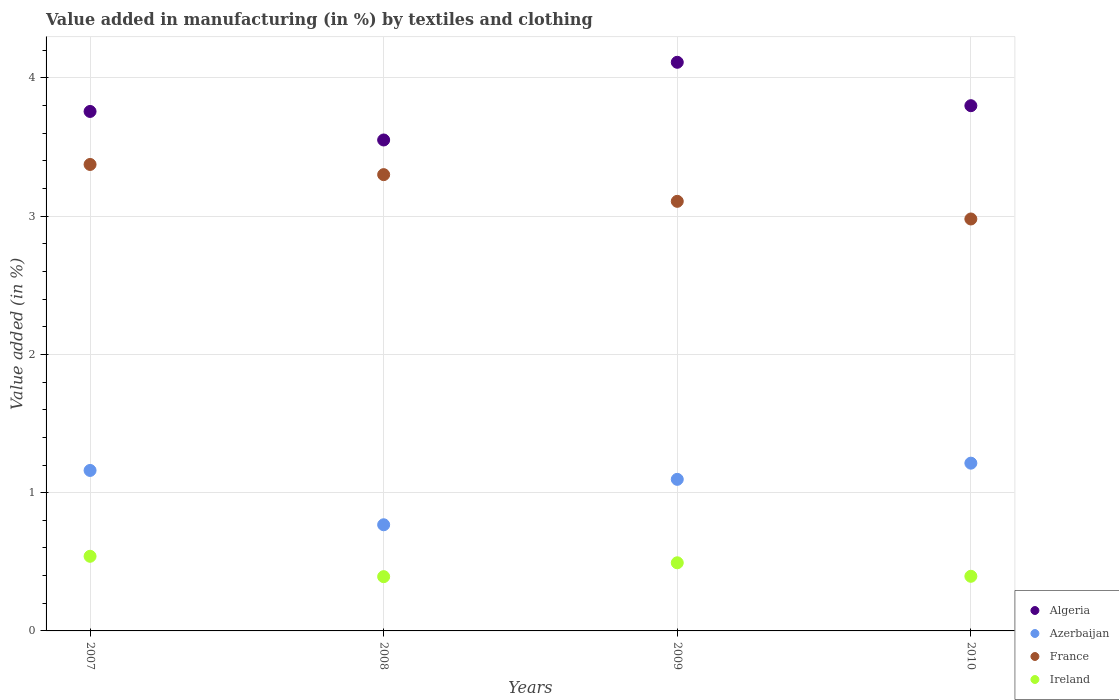How many different coloured dotlines are there?
Make the answer very short. 4. What is the percentage of value added in manufacturing by textiles and clothing in Azerbaijan in 2007?
Make the answer very short. 1.16. Across all years, what is the maximum percentage of value added in manufacturing by textiles and clothing in Ireland?
Offer a terse response. 0.54. Across all years, what is the minimum percentage of value added in manufacturing by textiles and clothing in Ireland?
Your answer should be very brief. 0.39. In which year was the percentage of value added in manufacturing by textiles and clothing in Azerbaijan maximum?
Offer a very short reply. 2010. What is the total percentage of value added in manufacturing by textiles and clothing in Algeria in the graph?
Your answer should be compact. 15.22. What is the difference between the percentage of value added in manufacturing by textiles and clothing in Azerbaijan in 2009 and that in 2010?
Offer a very short reply. -0.12. What is the difference between the percentage of value added in manufacturing by textiles and clothing in France in 2010 and the percentage of value added in manufacturing by textiles and clothing in Algeria in 2007?
Your response must be concise. -0.78. What is the average percentage of value added in manufacturing by textiles and clothing in Azerbaijan per year?
Provide a short and direct response. 1.06. In the year 2010, what is the difference between the percentage of value added in manufacturing by textiles and clothing in France and percentage of value added in manufacturing by textiles and clothing in Ireland?
Keep it short and to the point. 2.58. In how many years, is the percentage of value added in manufacturing by textiles and clothing in Algeria greater than 3.8 %?
Ensure brevity in your answer.  1. What is the ratio of the percentage of value added in manufacturing by textiles and clothing in Ireland in 2007 to that in 2009?
Provide a short and direct response. 1.1. Is the difference between the percentage of value added in manufacturing by textiles and clothing in France in 2007 and 2009 greater than the difference between the percentage of value added in manufacturing by textiles and clothing in Ireland in 2007 and 2009?
Keep it short and to the point. Yes. What is the difference between the highest and the second highest percentage of value added in manufacturing by textiles and clothing in France?
Provide a succinct answer. 0.07. What is the difference between the highest and the lowest percentage of value added in manufacturing by textiles and clothing in Ireland?
Make the answer very short. 0.15. Is it the case that in every year, the sum of the percentage of value added in manufacturing by textiles and clothing in France and percentage of value added in manufacturing by textiles and clothing in Algeria  is greater than the sum of percentage of value added in manufacturing by textiles and clothing in Ireland and percentage of value added in manufacturing by textiles and clothing in Azerbaijan?
Provide a short and direct response. Yes. Is the percentage of value added in manufacturing by textiles and clothing in France strictly greater than the percentage of value added in manufacturing by textiles and clothing in Algeria over the years?
Keep it short and to the point. No. How many dotlines are there?
Keep it short and to the point. 4. What is the difference between two consecutive major ticks on the Y-axis?
Make the answer very short. 1. Are the values on the major ticks of Y-axis written in scientific E-notation?
Your response must be concise. No. Where does the legend appear in the graph?
Your answer should be very brief. Bottom right. How many legend labels are there?
Keep it short and to the point. 4. How are the legend labels stacked?
Provide a short and direct response. Vertical. What is the title of the graph?
Your response must be concise. Value added in manufacturing (in %) by textiles and clothing. Does "Euro area" appear as one of the legend labels in the graph?
Provide a short and direct response. No. What is the label or title of the Y-axis?
Offer a terse response. Value added (in %). What is the Value added (in %) of Algeria in 2007?
Provide a short and direct response. 3.76. What is the Value added (in %) of Azerbaijan in 2007?
Give a very brief answer. 1.16. What is the Value added (in %) of France in 2007?
Provide a succinct answer. 3.37. What is the Value added (in %) of Ireland in 2007?
Give a very brief answer. 0.54. What is the Value added (in %) in Algeria in 2008?
Your answer should be very brief. 3.55. What is the Value added (in %) of Azerbaijan in 2008?
Your answer should be very brief. 0.77. What is the Value added (in %) of France in 2008?
Your answer should be very brief. 3.3. What is the Value added (in %) in Ireland in 2008?
Make the answer very short. 0.39. What is the Value added (in %) of Algeria in 2009?
Keep it short and to the point. 4.11. What is the Value added (in %) of Azerbaijan in 2009?
Your answer should be compact. 1.1. What is the Value added (in %) of France in 2009?
Your response must be concise. 3.11. What is the Value added (in %) in Ireland in 2009?
Provide a short and direct response. 0.49. What is the Value added (in %) in Algeria in 2010?
Your response must be concise. 3.8. What is the Value added (in %) in Azerbaijan in 2010?
Give a very brief answer. 1.21. What is the Value added (in %) in France in 2010?
Provide a short and direct response. 2.98. What is the Value added (in %) of Ireland in 2010?
Keep it short and to the point. 0.4. Across all years, what is the maximum Value added (in %) in Algeria?
Provide a succinct answer. 4.11. Across all years, what is the maximum Value added (in %) in Azerbaijan?
Keep it short and to the point. 1.21. Across all years, what is the maximum Value added (in %) of France?
Your answer should be compact. 3.37. Across all years, what is the maximum Value added (in %) of Ireland?
Provide a succinct answer. 0.54. Across all years, what is the minimum Value added (in %) in Algeria?
Make the answer very short. 3.55. Across all years, what is the minimum Value added (in %) in Azerbaijan?
Keep it short and to the point. 0.77. Across all years, what is the minimum Value added (in %) of France?
Offer a very short reply. 2.98. Across all years, what is the minimum Value added (in %) in Ireland?
Keep it short and to the point. 0.39. What is the total Value added (in %) in Algeria in the graph?
Offer a very short reply. 15.22. What is the total Value added (in %) in Azerbaijan in the graph?
Provide a short and direct response. 4.24. What is the total Value added (in %) in France in the graph?
Offer a very short reply. 12.76. What is the total Value added (in %) in Ireland in the graph?
Make the answer very short. 1.82. What is the difference between the Value added (in %) of Algeria in 2007 and that in 2008?
Provide a succinct answer. 0.21. What is the difference between the Value added (in %) of Azerbaijan in 2007 and that in 2008?
Offer a terse response. 0.39. What is the difference between the Value added (in %) in France in 2007 and that in 2008?
Provide a succinct answer. 0.07. What is the difference between the Value added (in %) of Ireland in 2007 and that in 2008?
Give a very brief answer. 0.15. What is the difference between the Value added (in %) in Algeria in 2007 and that in 2009?
Your answer should be compact. -0.36. What is the difference between the Value added (in %) in Azerbaijan in 2007 and that in 2009?
Your response must be concise. 0.06. What is the difference between the Value added (in %) in France in 2007 and that in 2009?
Ensure brevity in your answer.  0.27. What is the difference between the Value added (in %) of Ireland in 2007 and that in 2009?
Offer a very short reply. 0.05. What is the difference between the Value added (in %) of Algeria in 2007 and that in 2010?
Make the answer very short. -0.04. What is the difference between the Value added (in %) of Azerbaijan in 2007 and that in 2010?
Offer a very short reply. -0.05. What is the difference between the Value added (in %) in France in 2007 and that in 2010?
Your answer should be very brief. 0.39. What is the difference between the Value added (in %) of Ireland in 2007 and that in 2010?
Provide a succinct answer. 0.14. What is the difference between the Value added (in %) of Algeria in 2008 and that in 2009?
Give a very brief answer. -0.56. What is the difference between the Value added (in %) in Azerbaijan in 2008 and that in 2009?
Provide a short and direct response. -0.33. What is the difference between the Value added (in %) in France in 2008 and that in 2009?
Your response must be concise. 0.19. What is the difference between the Value added (in %) of Ireland in 2008 and that in 2009?
Offer a very short reply. -0.1. What is the difference between the Value added (in %) of Algeria in 2008 and that in 2010?
Provide a succinct answer. -0.25. What is the difference between the Value added (in %) of Azerbaijan in 2008 and that in 2010?
Keep it short and to the point. -0.45. What is the difference between the Value added (in %) in France in 2008 and that in 2010?
Keep it short and to the point. 0.32. What is the difference between the Value added (in %) in Ireland in 2008 and that in 2010?
Offer a terse response. -0. What is the difference between the Value added (in %) of Algeria in 2009 and that in 2010?
Offer a very short reply. 0.31. What is the difference between the Value added (in %) in Azerbaijan in 2009 and that in 2010?
Offer a terse response. -0.12. What is the difference between the Value added (in %) of France in 2009 and that in 2010?
Provide a succinct answer. 0.13. What is the difference between the Value added (in %) of Ireland in 2009 and that in 2010?
Your response must be concise. 0.1. What is the difference between the Value added (in %) of Algeria in 2007 and the Value added (in %) of Azerbaijan in 2008?
Offer a terse response. 2.99. What is the difference between the Value added (in %) in Algeria in 2007 and the Value added (in %) in France in 2008?
Make the answer very short. 0.46. What is the difference between the Value added (in %) in Algeria in 2007 and the Value added (in %) in Ireland in 2008?
Provide a short and direct response. 3.36. What is the difference between the Value added (in %) of Azerbaijan in 2007 and the Value added (in %) of France in 2008?
Offer a very short reply. -2.14. What is the difference between the Value added (in %) in Azerbaijan in 2007 and the Value added (in %) in Ireland in 2008?
Make the answer very short. 0.77. What is the difference between the Value added (in %) of France in 2007 and the Value added (in %) of Ireland in 2008?
Give a very brief answer. 2.98. What is the difference between the Value added (in %) of Algeria in 2007 and the Value added (in %) of Azerbaijan in 2009?
Provide a short and direct response. 2.66. What is the difference between the Value added (in %) in Algeria in 2007 and the Value added (in %) in France in 2009?
Make the answer very short. 0.65. What is the difference between the Value added (in %) of Algeria in 2007 and the Value added (in %) of Ireland in 2009?
Give a very brief answer. 3.26. What is the difference between the Value added (in %) in Azerbaijan in 2007 and the Value added (in %) in France in 2009?
Your answer should be compact. -1.95. What is the difference between the Value added (in %) in Azerbaijan in 2007 and the Value added (in %) in Ireland in 2009?
Give a very brief answer. 0.67. What is the difference between the Value added (in %) of France in 2007 and the Value added (in %) of Ireland in 2009?
Give a very brief answer. 2.88. What is the difference between the Value added (in %) in Algeria in 2007 and the Value added (in %) in Azerbaijan in 2010?
Your response must be concise. 2.54. What is the difference between the Value added (in %) in Algeria in 2007 and the Value added (in %) in France in 2010?
Keep it short and to the point. 0.78. What is the difference between the Value added (in %) in Algeria in 2007 and the Value added (in %) in Ireland in 2010?
Offer a very short reply. 3.36. What is the difference between the Value added (in %) of Azerbaijan in 2007 and the Value added (in %) of France in 2010?
Your answer should be very brief. -1.82. What is the difference between the Value added (in %) in Azerbaijan in 2007 and the Value added (in %) in Ireland in 2010?
Offer a very short reply. 0.77. What is the difference between the Value added (in %) of France in 2007 and the Value added (in %) of Ireland in 2010?
Offer a terse response. 2.98. What is the difference between the Value added (in %) of Algeria in 2008 and the Value added (in %) of Azerbaijan in 2009?
Offer a very short reply. 2.45. What is the difference between the Value added (in %) in Algeria in 2008 and the Value added (in %) in France in 2009?
Provide a short and direct response. 0.44. What is the difference between the Value added (in %) in Algeria in 2008 and the Value added (in %) in Ireland in 2009?
Provide a succinct answer. 3.06. What is the difference between the Value added (in %) of Azerbaijan in 2008 and the Value added (in %) of France in 2009?
Ensure brevity in your answer.  -2.34. What is the difference between the Value added (in %) in Azerbaijan in 2008 and the Value added (in %) in Ireland in 2009?
Make the answer very short. 0.27. What is the difference between the Value added (in %) of France in 2008 and the Value added (in %) of Ireland in 2009?
Keep it short and to the point. 2.81. What is the difference between the Value added (in %) of Algeria in 2008 and the Value added (in %) of Azerbaijan in 2010?
Your response must be concise. 2.34. What is the difference between the Value added (in %) in Algeria in 2008 and the Value added (in %) in France in 2010?
Your answer should be very brief. 0.57. What is the difference between the Value added (in %) of Algeria in 2008 and the Value added (in %) of Ireland in 2010?
Offer a terse response. 3.16. What is the difference between the Value added (in %) in Azerbaijan in 2008 and the Value added (in %) in France in 2010?
Ensure brevity in your answer.  -2.21. What is the difference between the Value added (in %) of Azerbaijan in 2008 and the Value added (in %) of Ireland in 2010?
Your answer should be very brief. 0.37. What is the difference between the Value added (in %) of France in 2008 and the Value added (in %) of Ireland in 2010?
Your answer should be compact. 2.9. What is the difference between the Value added (in %) in Algeria in 2009 and the Value added (in %) in Azerbaijan in 2010?
Give a very brief answer. 2.9. What is the difference between the Value added (in %) of Algeria in 2009 and the Value added (in %) of France in 2010?
Offer a terse response. 1.13. What is the difference between the Value added (in %) in Algeria in 2009 and the Value added (in %) in Ireland in 2010?
Provide a short and direct response. 3.72. What is the difference between the Value added (in %) of Azerbaijan in 2009 and the Value added (in %) of France in 2010?
Your answer should be compact. -1.88. What is the difference between the Value added (in %) of Azerbaijan in 2009 and the Value added (in %) of Ireland in 2010?
Offer a terse response. 0.7. What is the difference between the Value added (in %) of France in 2009 and the Value added (in %) of Ireland in 2010?
Your response must be concise. 2.71. What is the average Value added (in %) of Algeria per year?
Your answer should be compact. 3.8. What is the average Value added (in %) in Azerbaijan per year?
Keep it short and to the point. 1.06. What is the average Value added (in %) of France per year?
Make the answer very short. 3.19. What is the average Value added (in %) of Ireland per year?
Your response must be concise. 0.46. In the year 2007, what is the difference between the Value added (in %) in Algeria and Value added (in %) in Azerbaijan?
Your answer should be very brief. 2.6. In the year 2007, what is the difference between the Value added (in %) of Algeria and Value added (in %) of France?
Your response must be concise. 0.38. In the year 2007, what is the difference between the Value added (in %) in Algeria and Value added (in %) in Ireland?
Offer a terse response. 3.22. In the year 2007, what is the difference between the Value added (in %) of Azerbaijan and Value added (in %) of France?
Keep it short and to the point. -2.21. In the year 2007, what is the difference between the Value added (in %) in Azerbaijan and Value added (in %) in Ireland?
Your answer should be compact. 0.62. In the year 2007, what is the difference between the Value added (in %) in France and Value added (in %) in Ireland?
Make the answer very short. 2.83. In the year 2008, what is the difference between the Value added (in %) in Algeria and Value added (in %) in Azerbaijan?
Provide a short and direct response. 2.78. In the year 2008, what is the difference between the Value added (in %) of Algeria and Value added (in %) of France?
Give a very brief answer. 0.25. In the year 2008, what is the difference between the Value added (in %) of Algeria and Value added (in %) of Ireland?
Your answer should be compact. 3.16. In the year 2008, what is the difference between the Value added (in %) of Azerbaijan and Value added (in %) of France?
Provide a succinct answer. -2.53. In the year 2008, what is the difference between the Value added (in %) of Azerbaijan and Value added (in %) of Ireland?
Provide a short and direct response. 0.38. In the year 2008, what is the difference between the Value added (in %) of France and Value added (in %) of Ireland?
Ensure brevity in your answer.  2.91. In the year 2009, what is the difference between the Value added (in %) in Algeria and Value added (in %) in Azerbaijan?
Offer a very short reply. 3.02. In the year 2009, what is the difference between the Value added (in %) of Algeria and Value added (in %) of France?
Provide a succinct answer. 1.01. In the year 2009, what is the difference between the Value added (in %) in Algeria and Value added (in %) in Ireland?
Offer a terse response. 3.62. In the year 2009, what is the difference between the Value added (in %) in Azerbaijan and Value added (in %) in France?
Provide a short and direct response. -2.01. In the year 2009, what is the difference between the Value added (in %) in Azerbaijan and Value added (in %) in Ireland?
Your response must be concise. 0.6. In the year 2009, what is the difference between the Value added (in %) of France and Value added (in %) of Ireland?
Provide a succinct answer. 2.61. In the year 2010, what is the difference between the Value added (in %) of Algeria and Value added (in %) of Azerbaijan?
Offer a very short reply. 2.59. In the year 2010, what is the difference between the Value added (in %) of Algeria and Value added (in %) of France?
Offer a very short reply. 0.82. In the year 2010, what is the difference between the Value added (in %) in Algeria and Value added (in %) in Ireland?
Provide a short and direct response. 3.4. In the year 2010, what is the difference between the Value added (in %) in Azerbaijan and Value added (in %) in France?
Offer a terse response. -1.77. In the year 2010, what is the difference between the Value added (in %) in Azerbaijan and Value added (in %) in Ireland?
Your answer should be very brief. 0.82. In the year 2010, what is the difference between the Value added (in %) of France and Value added (in %) of Ireland?
Your response must be concise. 2.58. What is the ratio of the Value added (in %) in Algeria in 2007 to that in 2008?
Provide a succinct answer. 1.06. What is the ratio of the Value added (in %) of Azerbaijan in 2007 to that in 2008?
Provide a succinct answer. 1.51. What is the ratio of the Value added (in %) in France in 2007 to that in 2008?
Offer a terse response. 1.02. What is the ratio of the Value added (in %) in Ireland in 2007 to that in 2008?
Provide a short and direct response. 1.38. What is the ratio of the Value added (in %) of Algeria in 2007 to that in 2009?
Your response must be concise. 0.91. What is the ratio of the Value added (in %) in Azerbaijan in 2007 to that in 2009?
Give a very brief answer. 1.06. What is the ratio of the Value added (in %) in France in 2007 to that in 2009?
Provide a succinct answer. 1.09. What is the ratio of the Value added (in %) in Ireland in 2007 to that in 2009?
Provide a short and direct response. 1.1. What is the ratio of the Value added (in %) in Algeria in 2007 to that in 2010?
Offer a terse response. 0.99. What is the ratio of the Value added (in %) in Azerbaijan in 2007 to that in 2010?
Offer a terse response. 0.96. What is the ratio of the Value added (in %) of France in 2007 to that in 2010?
Your answer should be very brief. 1.13. What is the ratio of the Value added (in %) in Ireland in 2007 to that in 2010?
Keep it short and to the point. 1.37. What is the ratio of the Value added (in %) of Algeria in 2008 to that in 2009?
Offer a very short reply. 0.86. What is the ratio of the Value added (in %) of Azerbaijan in 2008 to that in 2009?
Give a very brief answer. 0.7. What is the ratio of the Value added (in %) of France in 2008 to that in 2009?
Ensure brevity in your answer.  1.06. What is the ratio of the Value added (in %) in Ireland in 2008 to that in 2009?
Your answer should be compact. 0.8. What is the ratio of the Value added (in %) of Algeria in 2008 to that in 2010?
Your answer should be compact. 0.93. What is the ratio of the Value added (in %) of Azerbaijan in 2008 to that in 2010?
Ensure brevity in your answer.  0.63. What is the ratio of the Value added (in %) of France in 2008 to that in 2010?
Provide a short and direct response. 1.11. What is the ratio of the Value added (in %) in Algeria in 2009 to that in 2010?
Provide a succinct answer. 1.08. What is the ratio of the Value added (in %) of Azerbaijan in 2009 to that in 2010?
Give a very brief answer. 0.9. What is the ratio of the Value added (in %) in France in 2009 to that in 2010?
Make the answer very short. 1.04. What is the ratio of the Value added (in %) of Ireland in 2009 to that in 2010?
Your answer should be compact. 1.25. What is the difference between the highest and the second highest Value added (in %) in Algeria?
Provide a short and direct response. 0.31. What is the difference between the highest and the second highest Value added (in %) in Azerbaijan?
Provide a succinct answer. 0.05. What is the difference between the highest and the second highest Value added (in %) in France?
Give a very brief answer. 0.07. What is the difference between the highest and the second highest Value added (in %) in Ireland?
Make the answer very short. 0.05. What is the difference between the highest and the lowest Value added (in %) in Algeria?
Your response must be concise. 0.56. What is the difference between the highest and the lowest Value added (in %) of Azerbaijan?
Make the answer very short. 0.45. What is the difference between the highest and the lowest Value added (in %) in France?
Make the answer very short. 0.39. What is the difference between the highest and the lowest Value added (in %) in Ireland?
Ensure brevity in your answer.  0.15. 